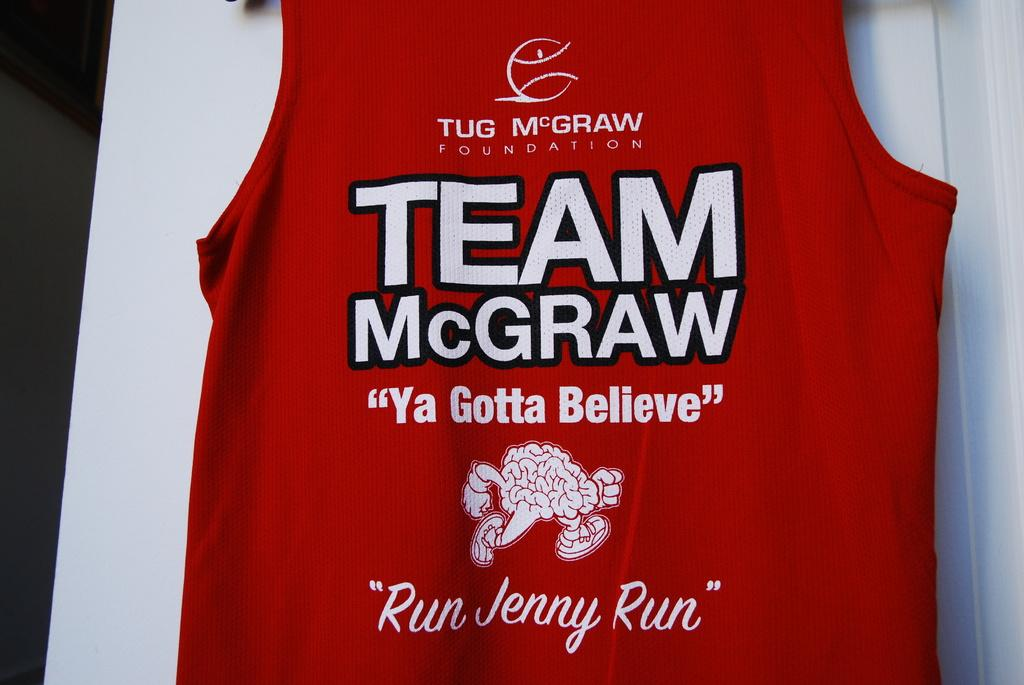<image>
Summarize the visual content of the image. a red jersey that had the name of Team McGraw on it 